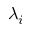Convert formula to latex. <formula><loc_0><loc_0><loc_500><loc_500>\lambda _ { i }</formula> 